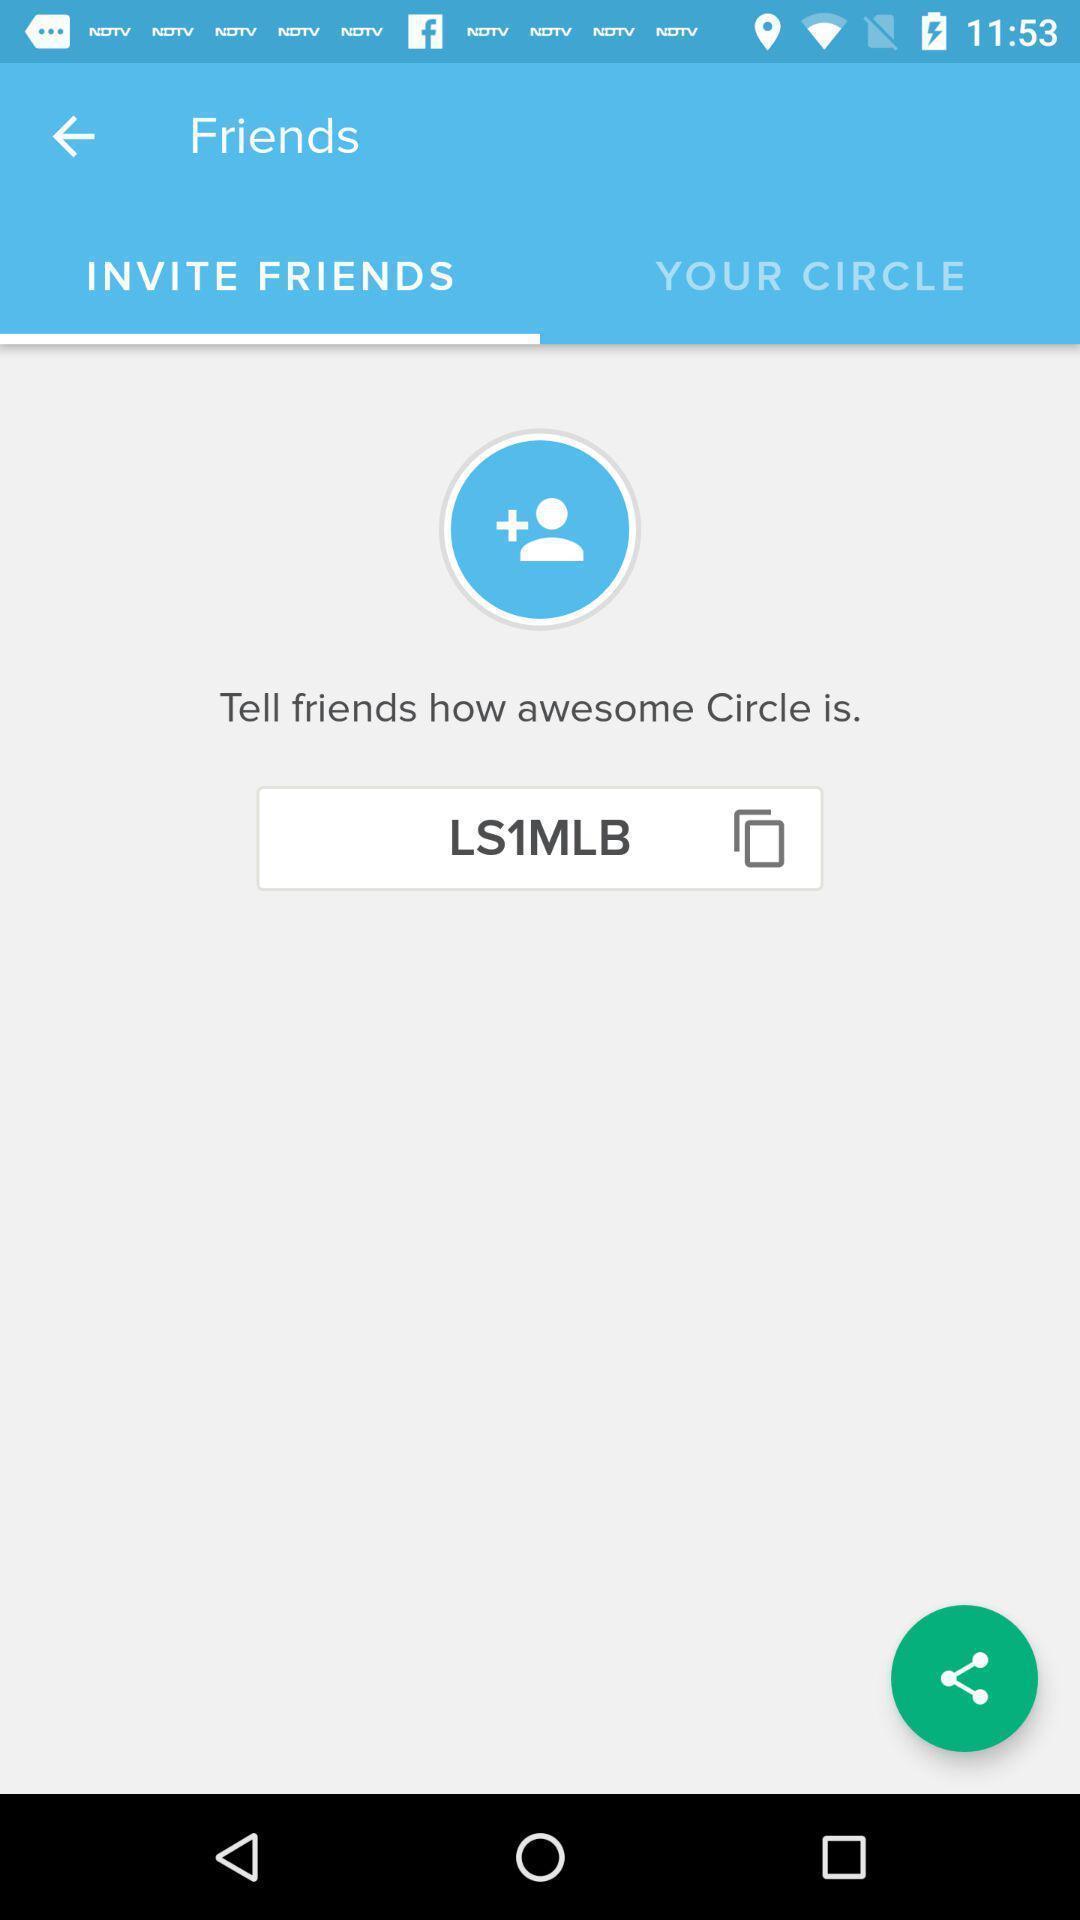Provide a description of this screenshot. Page shows to invite the friends and to share. 